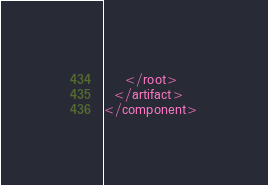<code> <loc_0><loc_0><loc_500><loc_500><_XML_>    </root>
  </artifact>
</component></code> 